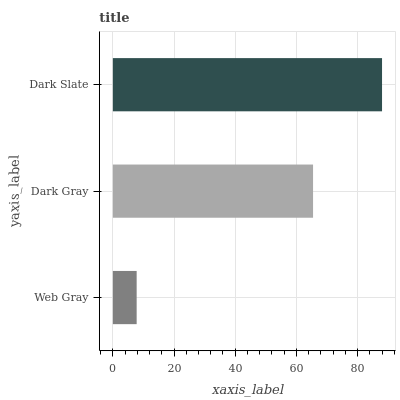Is Web Gray the minimum?
Answer yes or no. Yes. Is Dark Slate the maximum?
Answer yes or no. Yes. Is Dark Gray the minimum?
Answer yes or no. No. Is Dark Gray the maximum?
Answer yes or no. No. Is Dark Gray greater than Web Gray?
Answer yes or no. Yes. Is Web Gray less than Dark Gray?
Answer yes or no. Yes. Is Web Gray greater than Dark Gray?
Answer yes or no. No. Is Dark Gray less than Web Gray?
Answer yes or no. No. Is Dark Gray the high median?
Answer yes or no. Yes. Is Dark Gray the low median?
Answer yes or no. Yes. Is Dark Slate the high median?
Answer yes or no. No. Is Web Gray the low median?
Answer yes or no. No. 